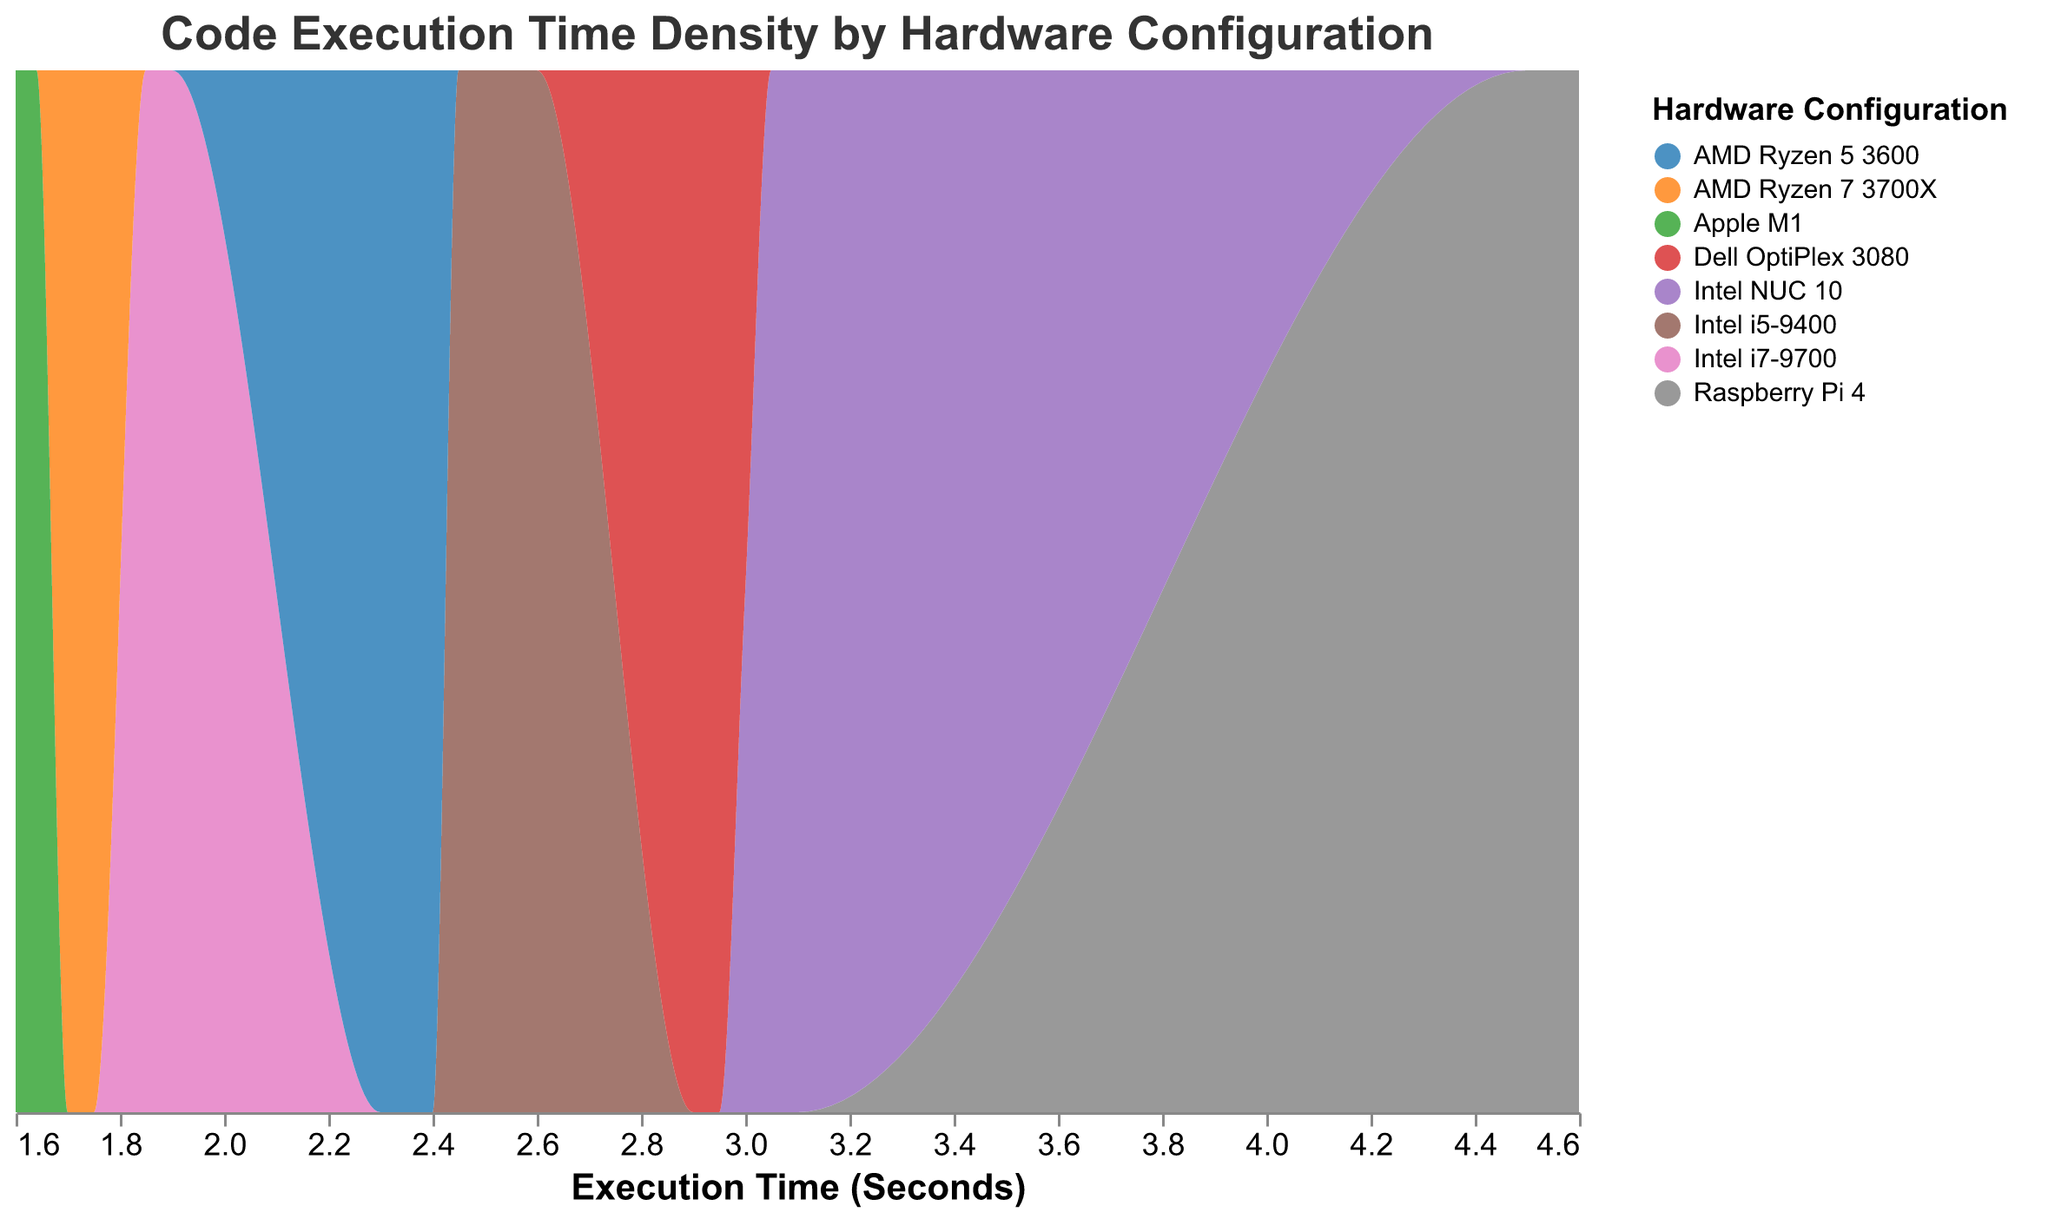What is the title of the plot? The title is displayed at the top of the plot and reads "Code Execution Time Density by Hardware Configuration"
Answer: Code Execution Time Density by Hardware Configuration What does the x-axis represent? The x-axis represents the "Code Execution Time (Seconds)" which shows the execution time in seconds for different hardware configurations
Answer: Execution Time (Seconds) Which hardware configuration has the highest execution time? The plot shows execution times for various hardware configurations. By examining the x-axis, the "Raspberry Pi 4" has the highest execution time, as its data points extend to the rightmost position
Answer: Raspberry Pi 4 How many data points are there for the "Apple M1"? The legend indicates hardware configurations by color, and the plot uses these colors to represent data points. Counting the points, the "Apple M1" has 3 data points
Answer: 3 Which hardware configuration has the lowest execution time? By examining the x-axis for the lowest values, the "Apple M1" has data points at the lowest time intervals
Answer: Apple M1 Compare the execution times between "Intel i5-9400" and "AMD Ryzen 5 3600". Which one is generally faster? Comparing their ranges on the x-axis, "AMD Ryzen 5 3600" has lower execution times (2.30–2.40 seconds) than "Intel i5-9400" (2.45–2.60 seconds)
Answer: AMD Ryzen 5 3600 Which hardware configurations have overlapping execution time ranges? By examining the plot, "Intel NUC 10" and "Dell OptiPlex 3080" overlap around 3.00 seconds
Answer: Intel NUC 10 and Dell OptiPlex 3080 What inference can be made about the density of the execution times? The area under the density curve indicates the frequency of execution times; more densely populated areas suggest more common execution times within that range
Answer: More density indicates more common execution times Are the execution times for the "Raspberry Pi 4" more spread out compared to other configurations? Yes, the "Raspberry Pi 4" shows a wider spread on the x-axis (4.50–4.60 seconds) compared to other configurations, indicating more variability in its execution times
Answer: Yes Which hardware configuration has most of its execution times clustered closely together on the x-axis? "Apple M1" has its execution times closely clustered between 1.60 and 1.64 seconds, suggesting very consistent performance
Answer: Apple M1 